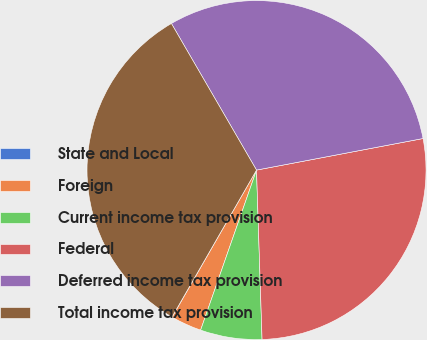Convert chart to OTSL. <chart><loc_0><loc_0><loc_500><loc_500><pie_chart><fcel>State and Local<fcel>Foreign<fcel>Current income tax provision<fcel>Federal<fcel>Deferred income tax provision<fcel>Total income tax provision<nl><fcel>0.02%<fcel>2.94%<fcel>5.87%<fcel>27.46%<fcel>30.39%<fcel>33.32%<nl></chart> 